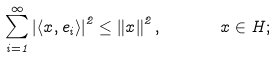Convert formula to latex. <formula><loc_0><loc_0><loc_500><loc_500>\sum _ { i = 1 } ^ { \infty } \left | \left \langle x , e _ { i } \right \rangle \right | ^ { 2 } \leq \left \| x \right \| ^ { 2 } , \quad \ \ x \in H ;</formula> 